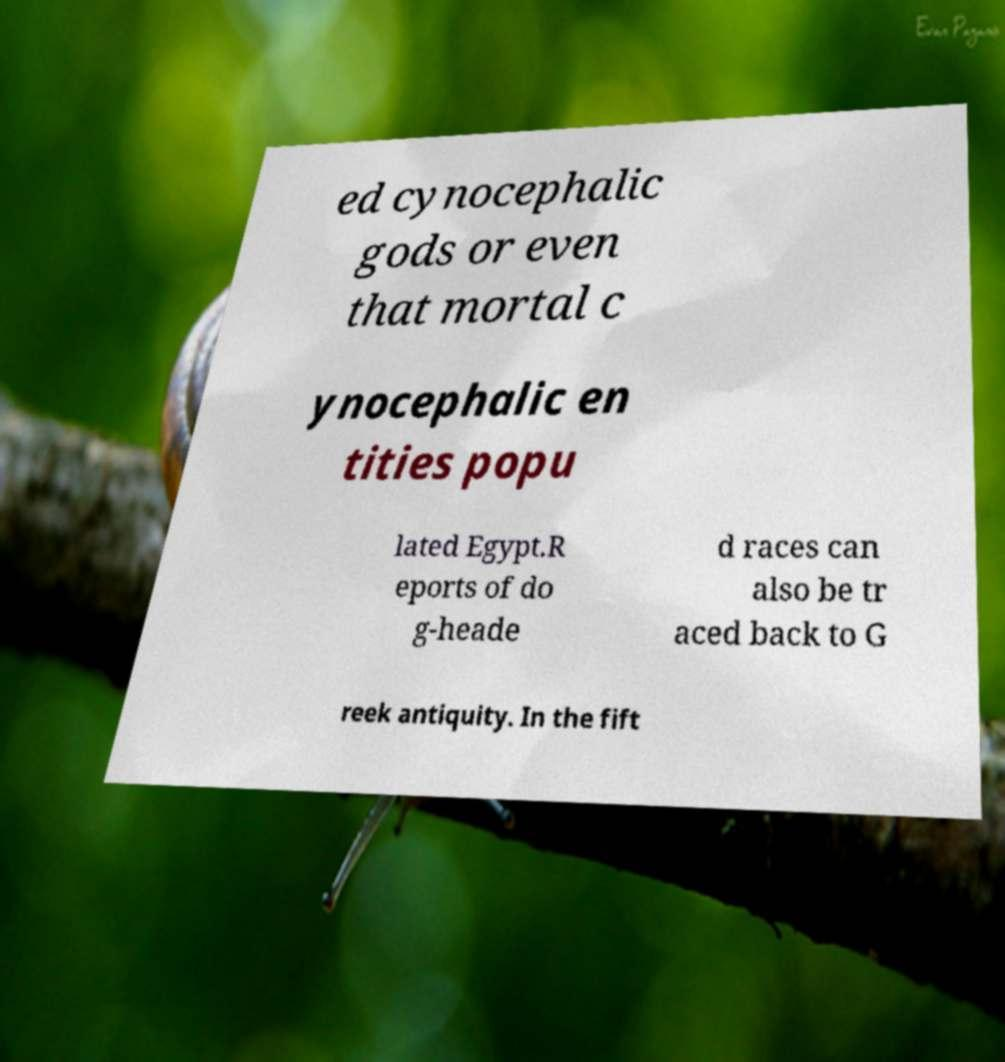Can you accurately transcribe the text from the provided image for me? ed cynocephalic gods or even that mortal c ynocephalic en tities popu lated Egypt.R eports of do g-heade d races can also be tr aced back to G reek antiquity. In the fift 